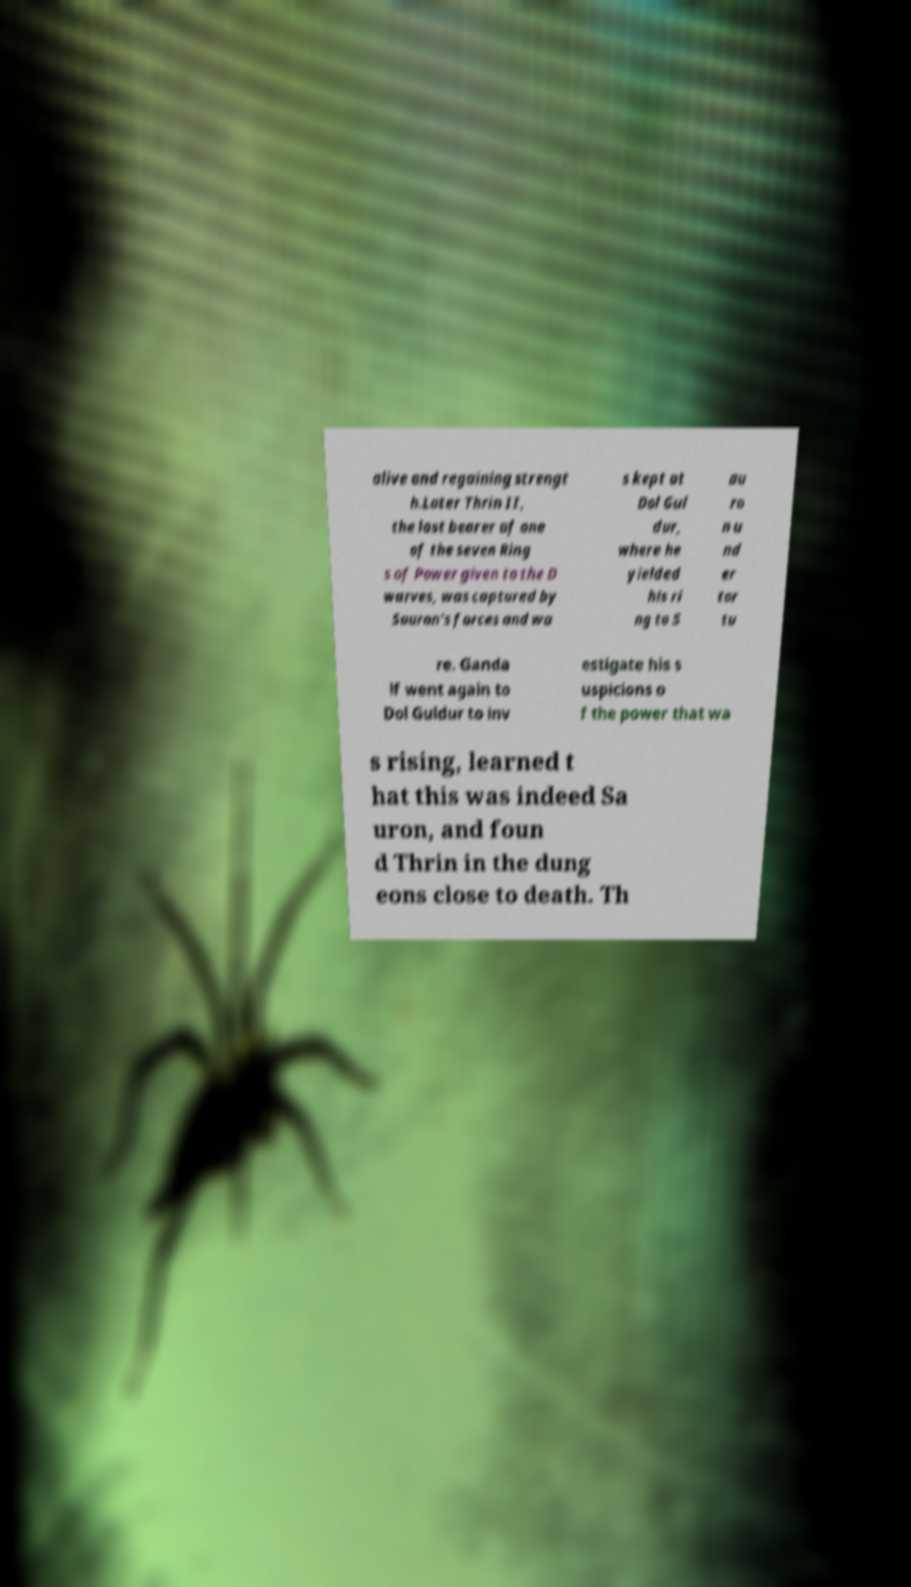What messages or text are displayed in this image? I need them in a readable, typed format. alive and regaining strengt h.Later Thrin II, the last bearer of one of the seven Ring s of Power given to the D warves, was captured by Sauron's forces and wa s kept at Dol Gul dur, where he yielded his ri ng to S au ro n u nd er tor tu re. Ganda lf went again to Dol Guldur to inv estigate his s uspicions o f the power that wa s rising, learned t hat this was indeed Sa uron, and foun d Thrin in the dung eons close to death. Th 